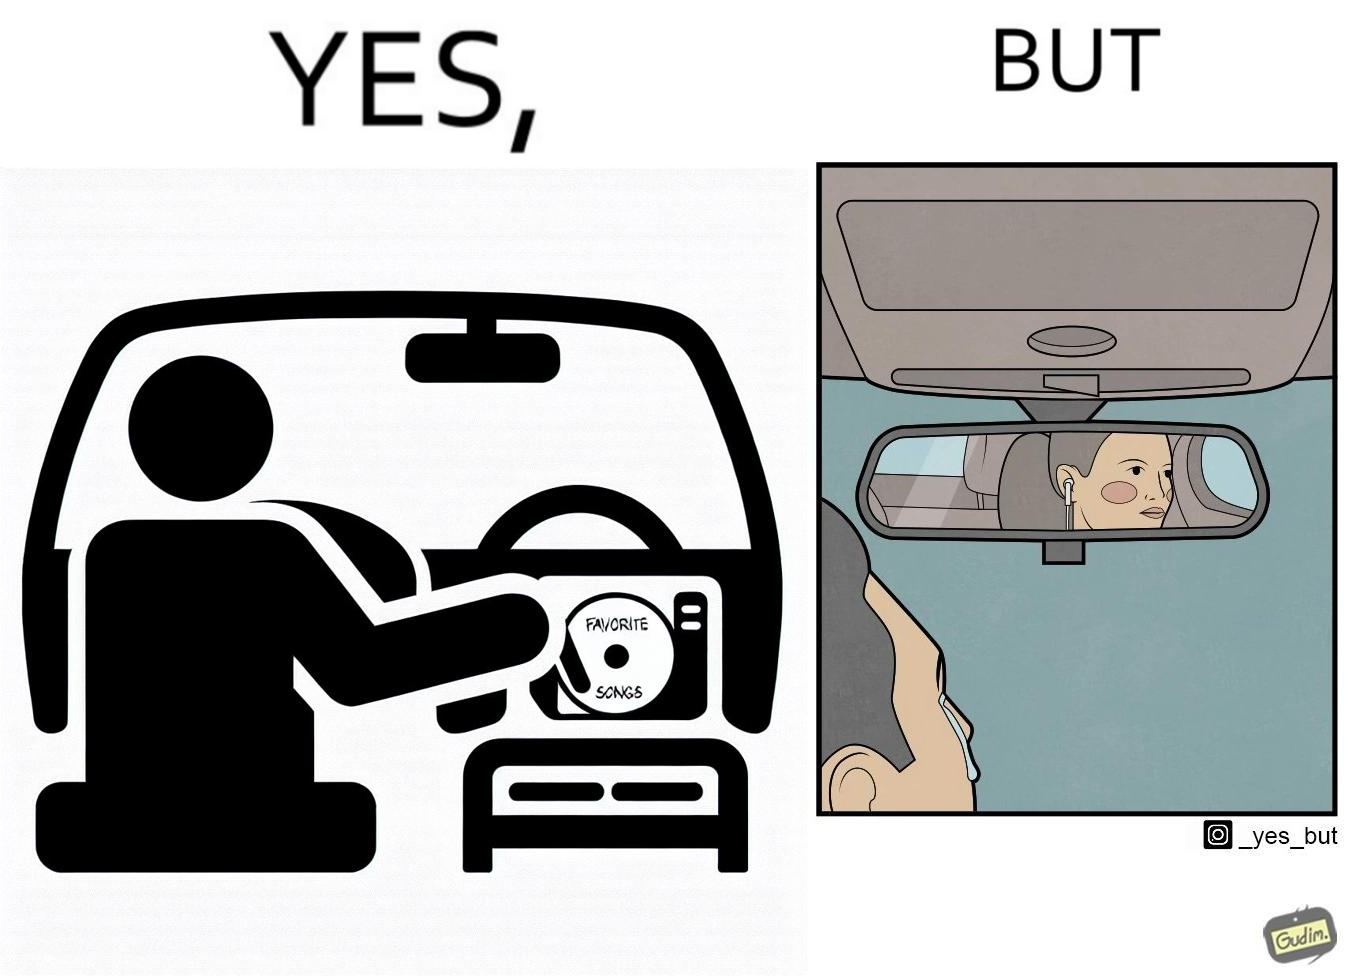Would you classify this image as satirical? Yes, this image is satirical. 